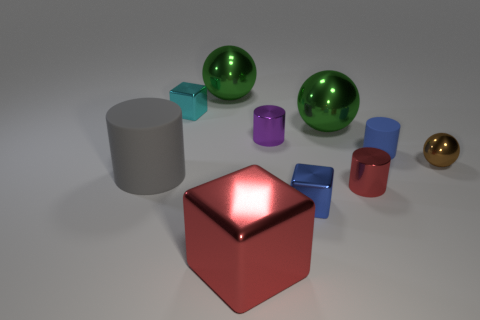How many small red metallic objects are the same shape as the big red object?
Ensure brevity in your answer.  0. There is a ball that is right of the small red object; what material is it?
Provide a succinct answer. Metal. Are there fewer tiny metallic objects to the left of the small purple metallic thing than tiny blue cylinders?
Your answer should be very brief. No. Do the blue rubber thing and the purple thing have the same shape?
Your response must be concise. Yes. Is there any other thing that is the same shape as the cyan metal thing?
Offer a very short reply. Yes. Are any purple shiny cylinders visible?
Keep it short and to the point. Yes. There is a large red metallic thing; does it have the same shape as the big green object that is left of the small purple thing?
Your response must be concise. No. What is the material of the tiny cube behind the sphere that is to the right of the small blue rubber object?
Your answer should be very brief. Metal. The tiny rubber cylinder is what color?
Offer a terse response. Blue. Do the shiny ball that is in front of the small blue rubber cylinder and the small shiny cube behind the tiny blue matte cylinder have the same color?
Keep it short and to the point. No. 